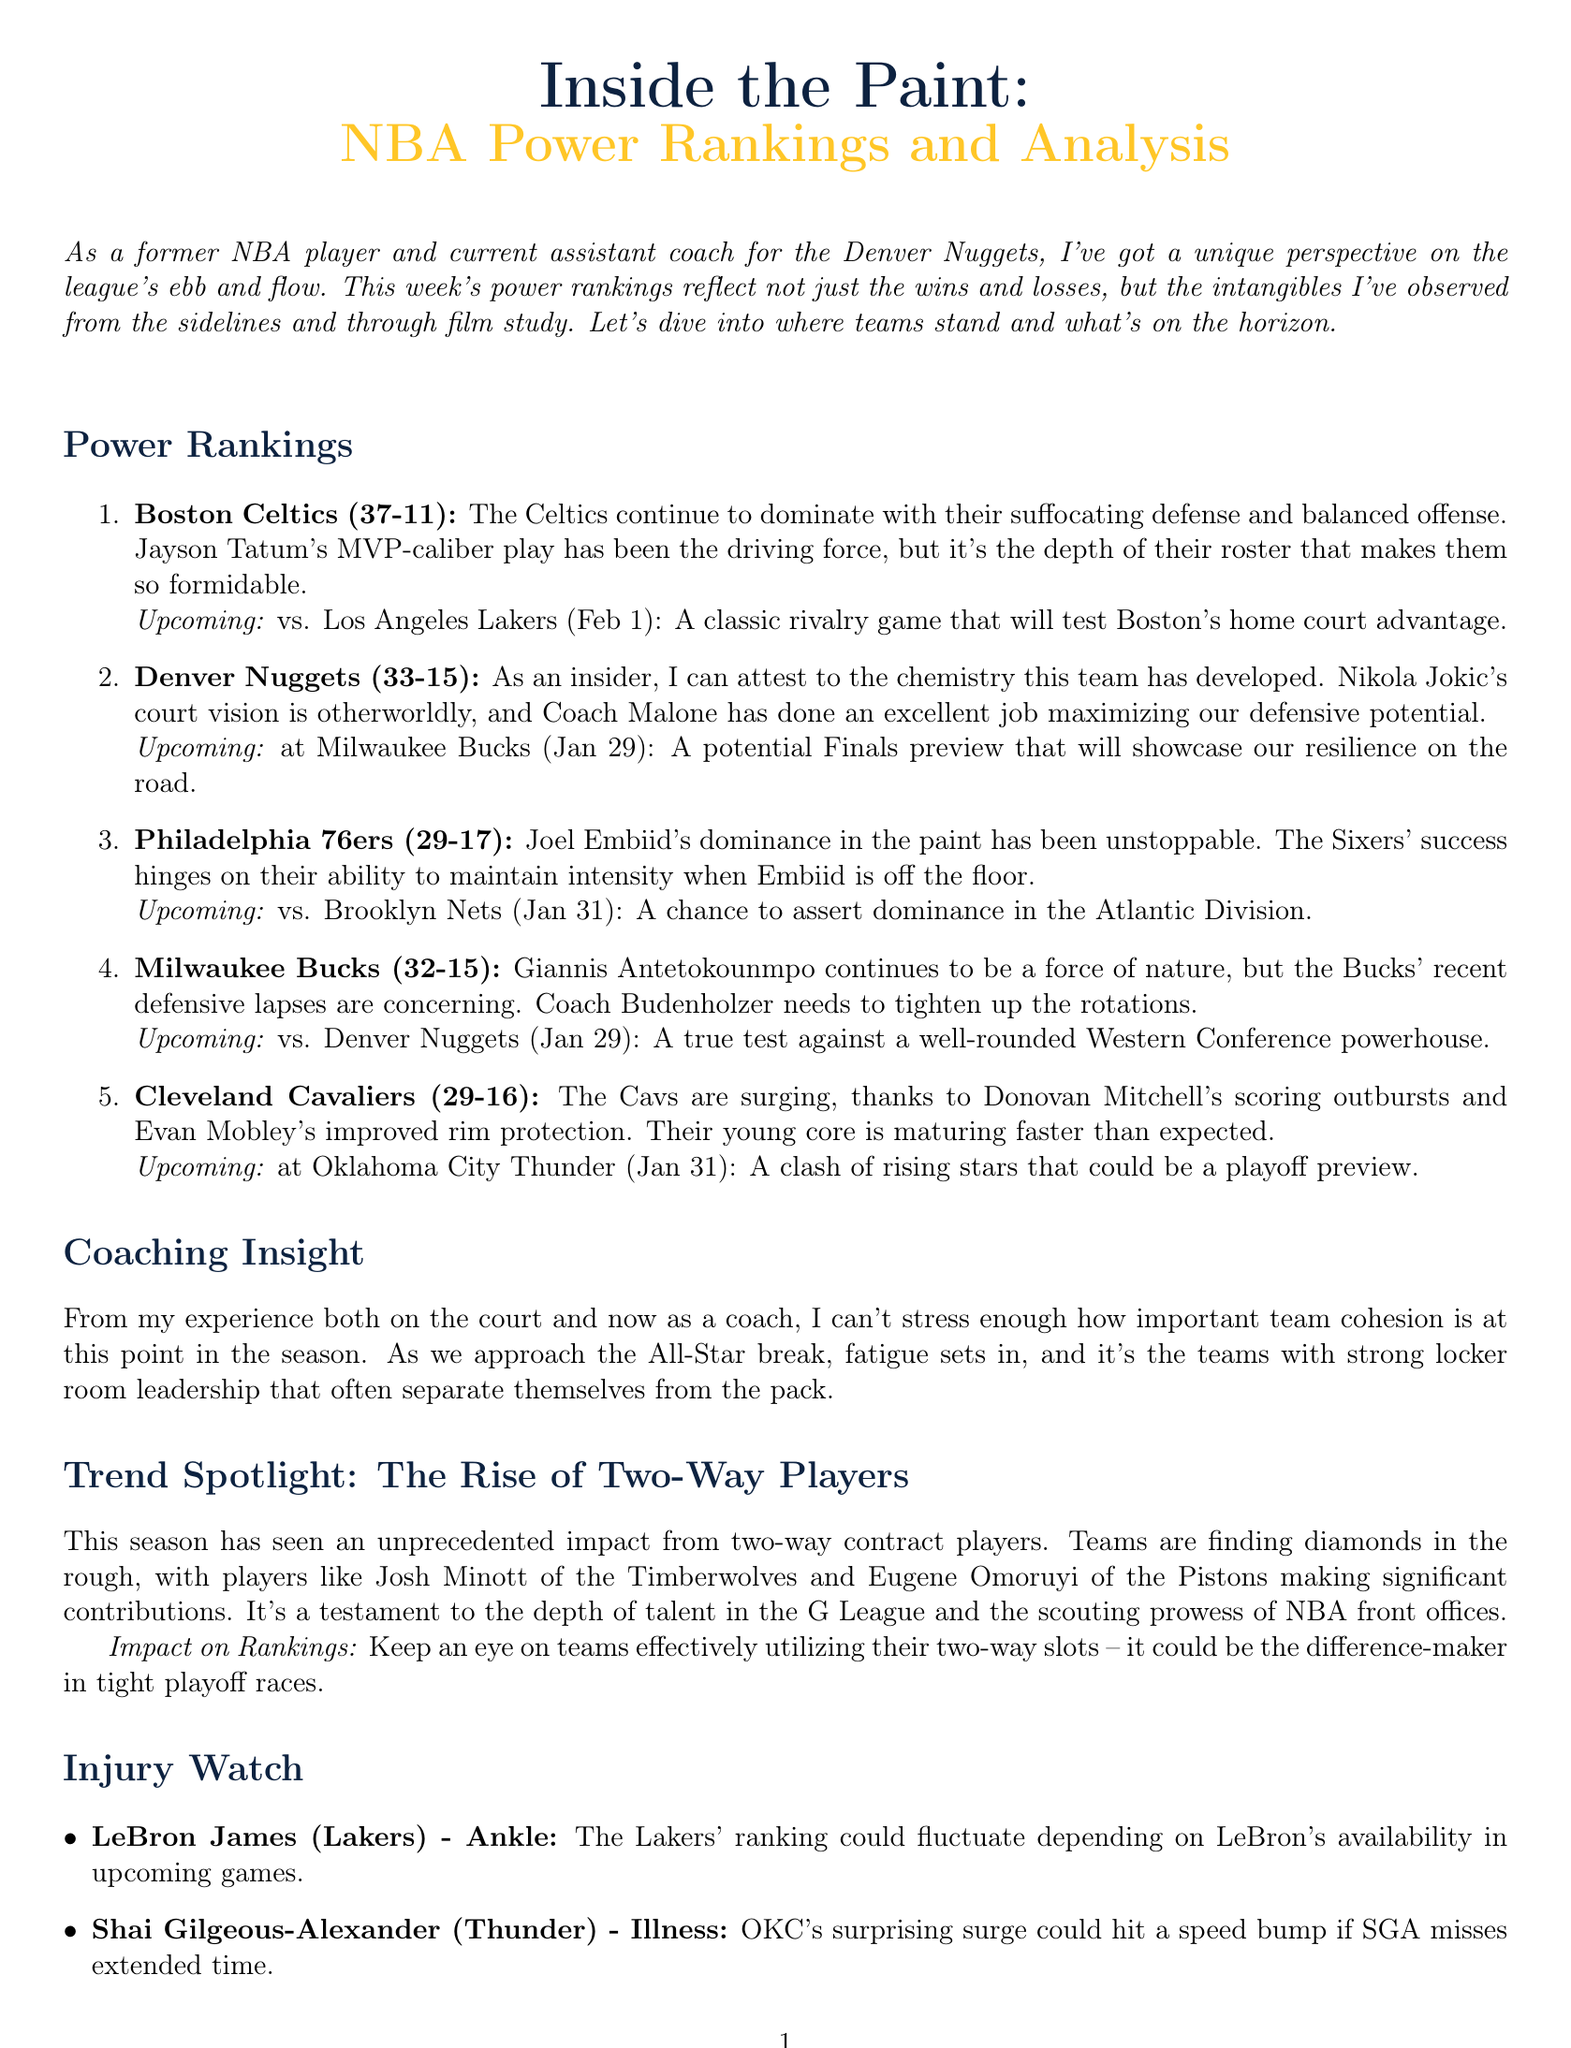What is the title of the newsletter? The title is stated at the beginning of the document and is "Inside the Paint: NBA Power Rankings and Analysis."
Answer: Inside the Paint: NBA Power Rankings and Analysis Who is currently ranked 2nd? The ranking is found in the power rankings section, listing the teams with their respective ranks.
Answer: Denver Nuggets What is the record of the Boston Celtics? The record is specified directly after the team name in the rankings section.
Answer: 37-11 What is the upcoming matchup for the Cleveland Cavaliers? The upcoming matchup is described in the context of the power rankings alongside the team analysis.
Answer: at Oklahoma City Thunder (Jan 31) What is the main focus of the coaching insight? The insight discusses general observations from the author's experience that relates to team dynamics.
Answer: Team cohesion How has LeBron James' injury impacted the Lakers' ranking? The injury watch section outlines the potential effects of player injuries on team performance.
Answer: Could fluctuate depending on LeBron's availability What is the trend discussed in the document? The trend spotlight highlights an observable phenomenon affecting teams this season.
Answer: The Rise of Two-Way Players Which player is mentioned in the injury watch section due to illness? The injury watch lists players and their conditions, indicating their potential impact on games.
Answer: Shai Gilgeous-Alexander What does Coach Malone maximize according to the analysis of the Nuggets? The analysis provides insight into the team's defensive efforts under the coach's leadership.
Answer: Defensive potential 